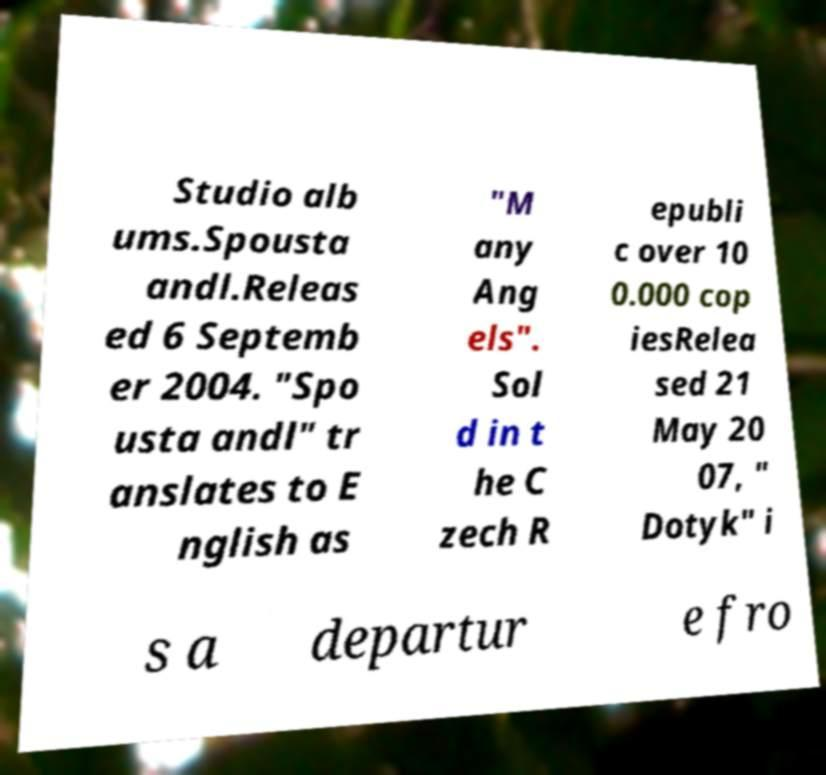Please read and relay the text visible in this image. What does it say? Studio alb ums.Spousta andl.Releas ed 6 Septemb er 2004. "Spo usta andl" tr anslates to E nglish as "M any Ang els". Sol d in t he C zech R epubli c over 10 0.000 cop iesRelea sed 21 May 20 07, " Dotyk" i s a departur e fro 